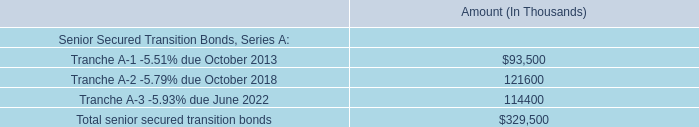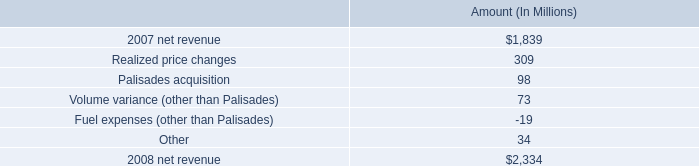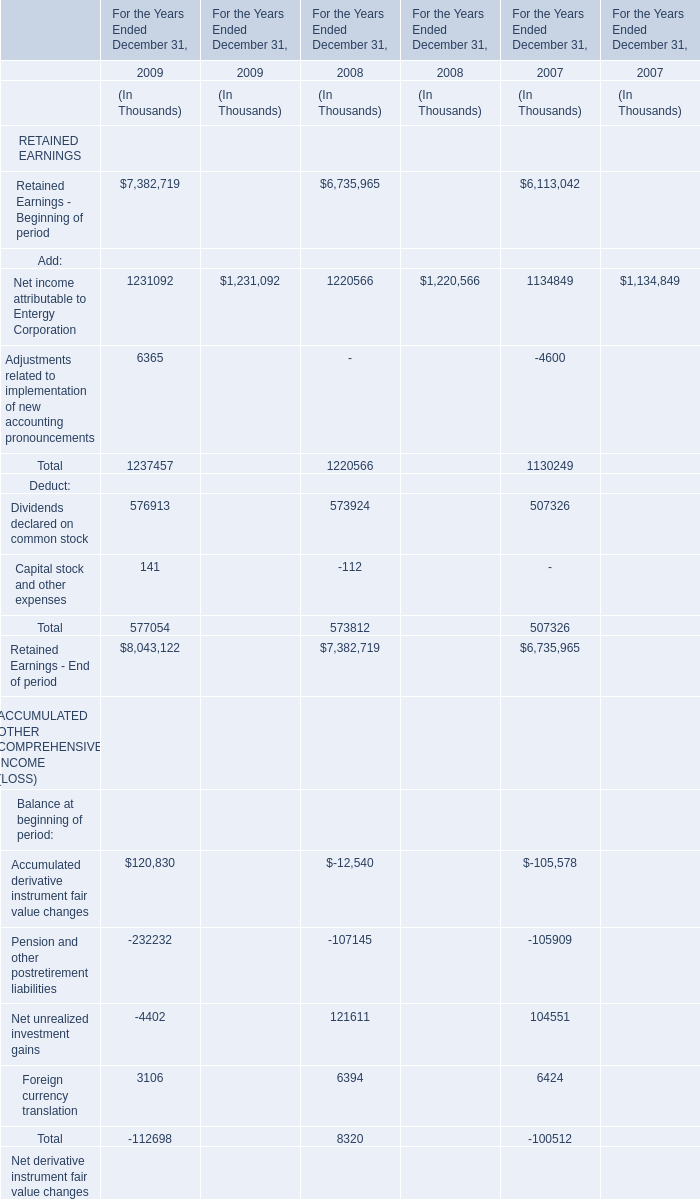what portion of the increase in net revenue from non-utility nuclear is attributed to the palisades acquisition? 
Computations: (98 / 495)
Answer: 0.19798. 